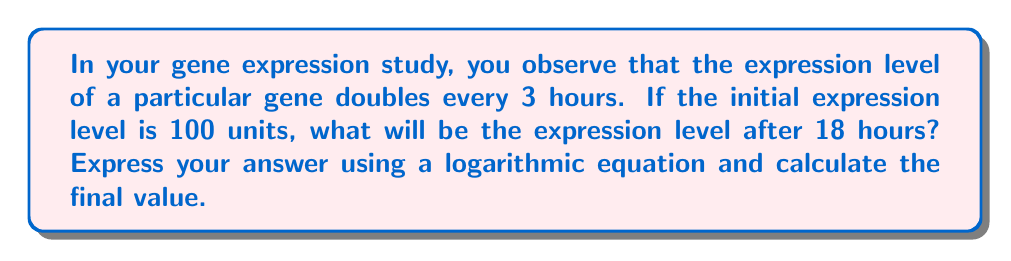Could you help me with this problem? Let's approach this step-by-step:

1) First, we need to identify the exponential growth equation:
   $A = A_0 \cdot 2^{t/3}$
   Where $A$ is the final amount, $A_0$ is the initial amount, and $t$ is the time in hours.

2) We know:
   $A_0 = 100$ units
   $t = 18$ hours

3) Let's substitute these values into our equation:
   $A = 100 \cdot 2^{18/3}$

4) Simplify the exponent:
   $A = 100 \cdot 2^6$

5) Now, we can calculate this:
   $A = 100 \cdot 64 = 6400$ units

6) To express this using a logarithmic equation, we can use the properties of logarithms:
   $\log_2 A = \log_2 (100 \cdot 2^6)$
   $\log_2 A = \log_2 100 + 6$

7) We can further simplify $\log_2 100$:
   $\log_2 100 = \log_2 (2^{6.64386}) \approx 6.64386$
   (This is because $2^{6.64386} \approx 100$)

8) Therefore, our final logarithmic equation is:
   $\log_2 A \approx 6.64386 + 6 = 12.64386$

9) To get back to $A$, we can use the inverse function:
   $A = 2^{12.64386} \approx 6400$ units
Answer: $A = 100 \cdot 2^6 = 6400$ units; $\log_2 A \approx 12.64386$ 